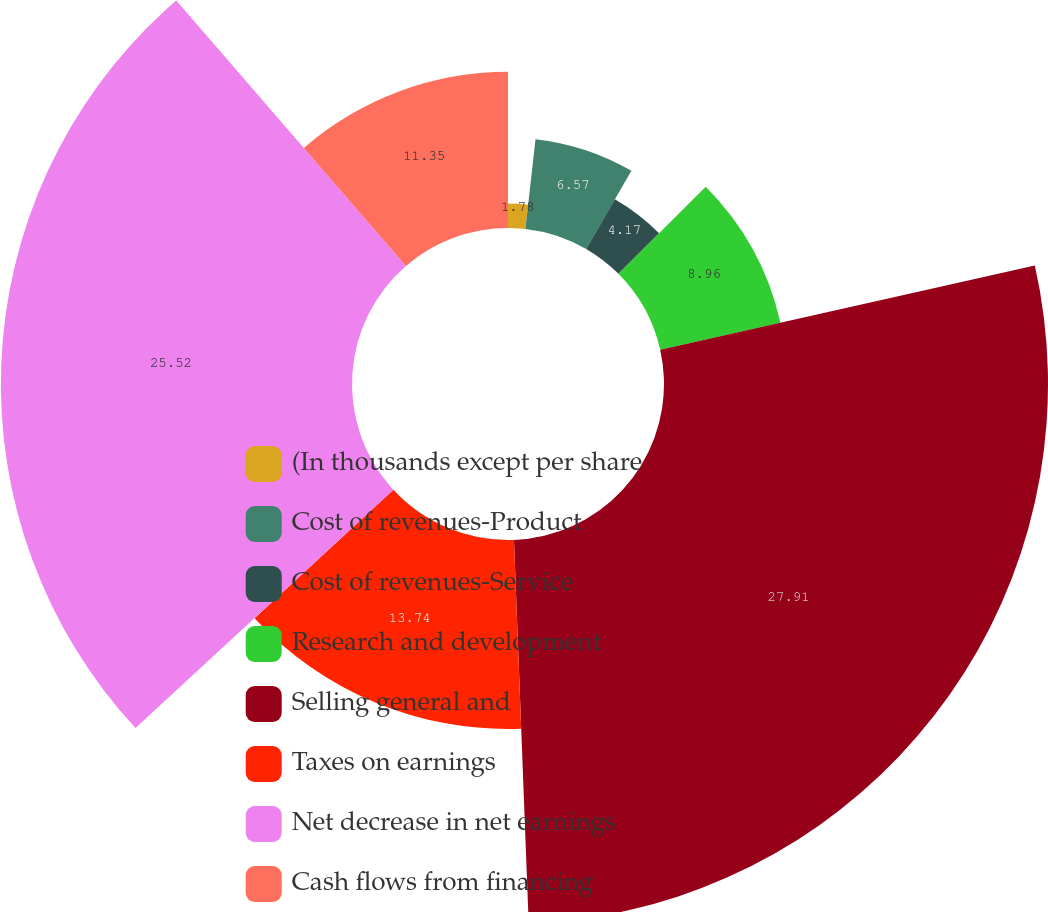<chart> <loc_0><loc_0><loc_500><loc_500><pie_chart><fcel>(In thousands except per share<fcel>Cost of revenues-Product<fcel>Cost of revenues-Service<fcel>Research and development<fcel>Selling general and<fcel>Taxes on earnings<fcel>Net decrease in net earnings<fcel>Cash flows from financing<nl><fcel>1.78%<fcel>6.57%<fcel>4.17%<fcel>8.96%<fcel>27.91%<fcel>13.74%<fcel>25.52%<fcel>11.35%<nl></chart> 